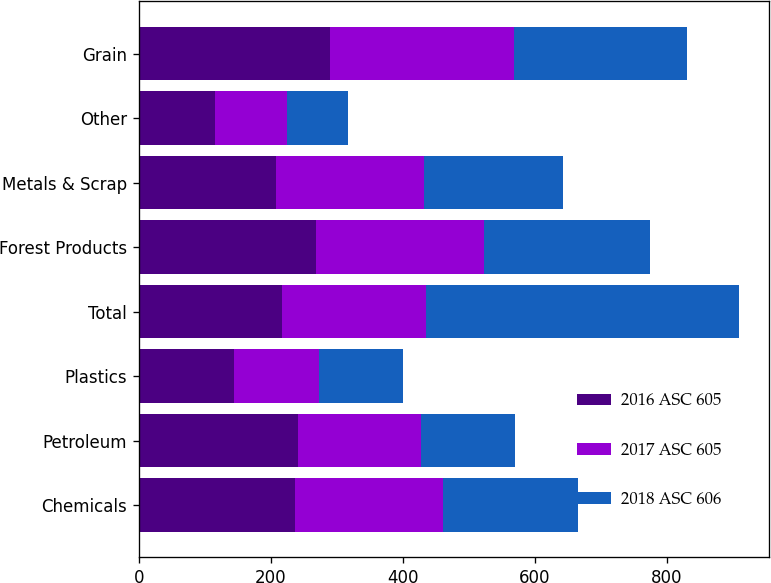Convert chart. <chart><loc_0><loc_0><loc_500><loc_500><stacked_bar_chart><ecel><fcel>Chemicals<fcel>Petroleum<fcel>Plastics<fcel>Total<fcel>Forest Products<fcel>Metals & Scrap<fcel>Other<fcel>Grain<nl><fcel>2016 ASC 605<fcel>236.3<fcel>241.9<fcel>143.9<fcel>217.25<fcel>268<fcel>208.2<fcel>114.8<fcel>289.9<nl><fcel>2017 ASC 605<fcel>225.1<fcel>186<fcel>128.8<fcel>217.25<fcel>255.8<fcel>223.3<fcel>109.2<fcel>278.1<nl><fcel>2018 ASC 606<fcel>204.7<fcel>142.5<fcel>128.2<fcel>475.4<fcel>250.2<fcel>211.2<fcel>92.6<fcel>262.9<nl></chart> 